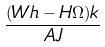<formula> <loc_0><loc_0><loc_500><loc_500>\frac { ( W h - H \Omega ) k } { A J }</formula> 